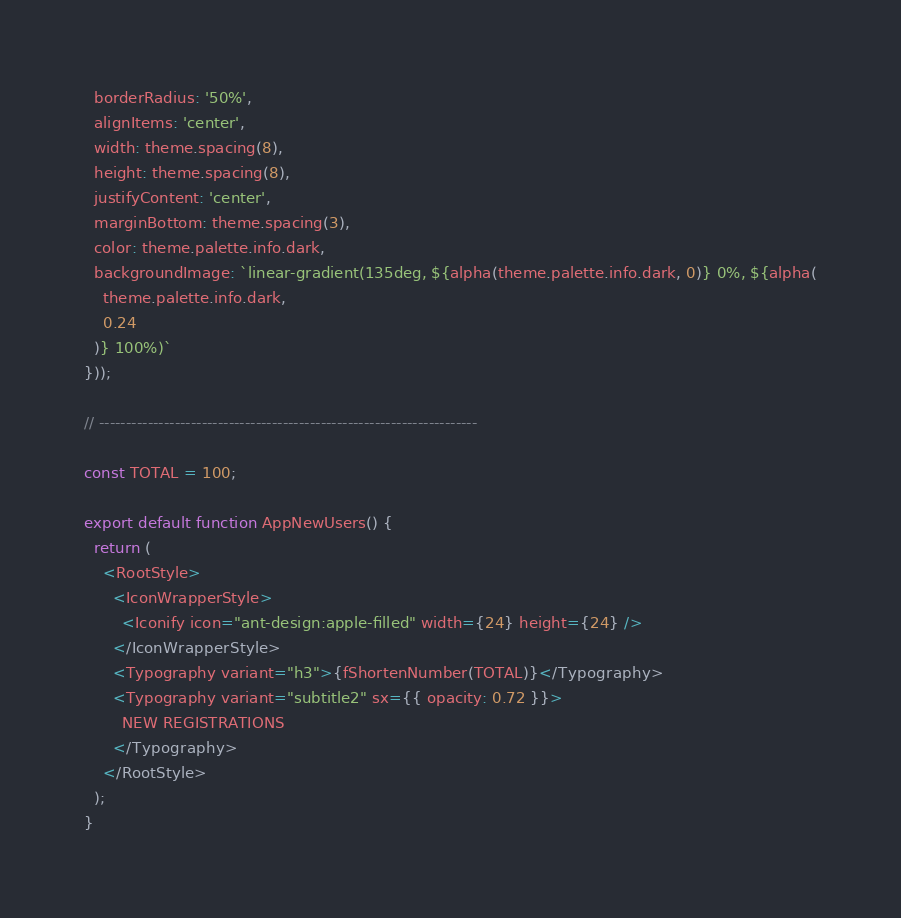<code> <loc_0><loc_0><loc_500><loc_500><_JavaScript_>  borderRadius: '50%',
  alignItems: 'center',
  width: theme.spacing(8),
  height: theme.spacing(8),
  justifyContent: 'center',
  marginBottom: theme.spacing(3),
  color: theme.palette.info.dark,
  backgroundImage: `linear-gradient(135deg, ${alpha(theme.palette.info.dark, 0)} 0%, ${alpha(
    theme.palette.info.dark,
    0.24
  )} 100%)`
}));

// ----------------------------------------------------------------------

const TOTAL = 100;

export default function AppNewUsers() {
  return (
    <RootStyle>
      <IconWrapperStyle>
        <Iconify icon="ant-design:apple-filled" width={24} height={24} />
      </IconWrapperStyle>
      <Typography variant="h3">{fShortenNumber(TOTAL)}</Typography>
      <Typography variant="subtitle2" sx={{ opacity: 0.72 }}>
        NEW REGISTRATIONS
      </Typography>
    </RootStyle>
  );
}
</code> 